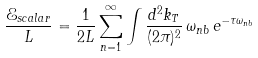<formula> <loc_0><loc_0><loc_500><loc_500>\frac { \mathcal { E } _ { s c a l a r } } { L } = \frac { 1 } { 2 L } \sum _ { n = 1 } ^ { \infty } \int \frac { d ^ { 2 } k _ { T } } { ( 2 \pi ) ^ { 2 } } { \, } \omega _ { n b } { \, } e ^ { - \tau \omega _ { n b } }</formula> 